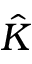<formula> <loc_0><loc_0><loc_500><loc_500>\hat { K }</formula> 